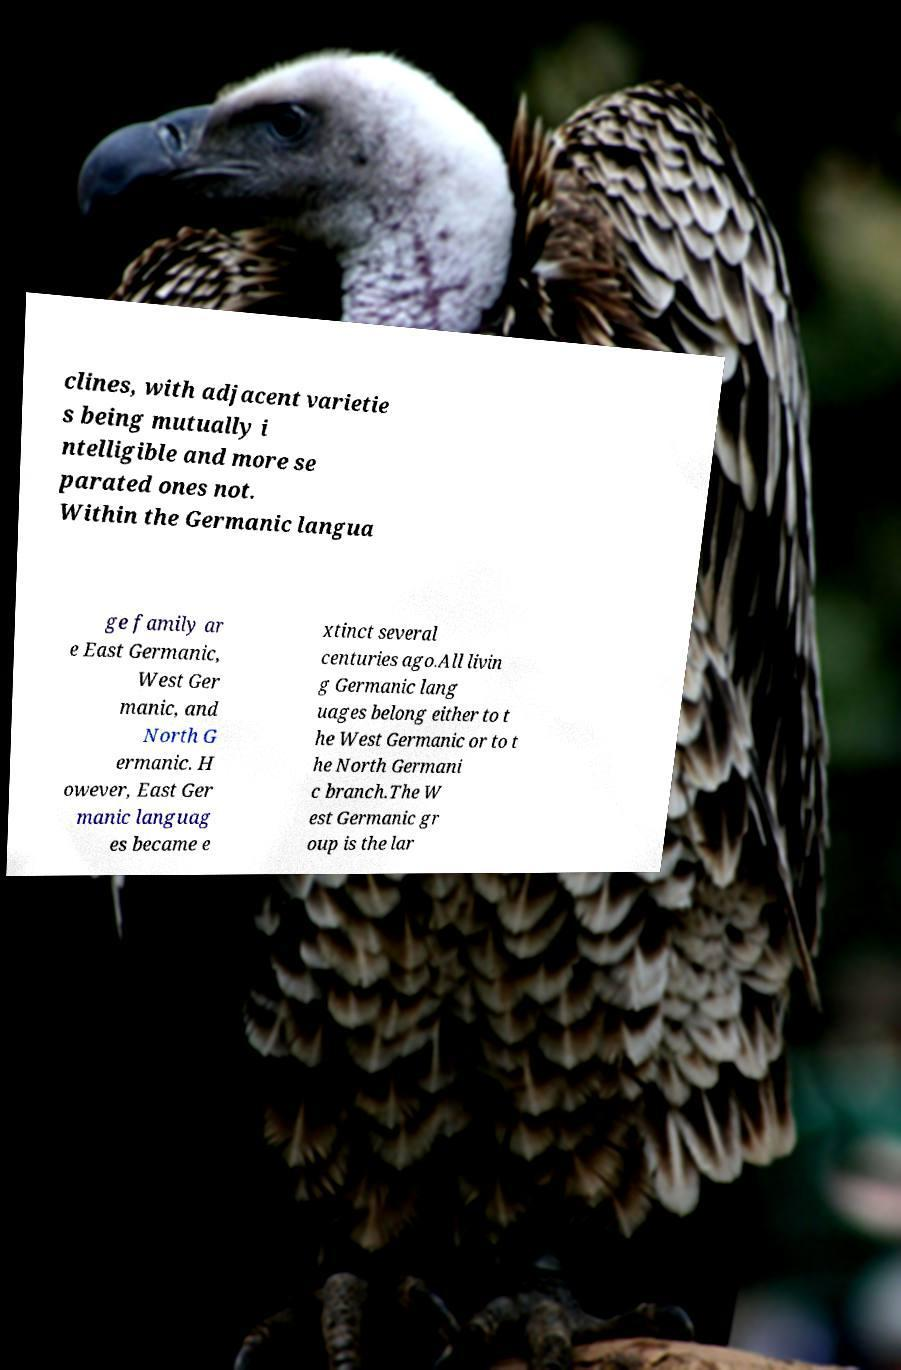Could you extract and type out the text from this image? clines, with adjacent varietie s being mutually i ntelligible and more se parated ones not. Within the Germanic langua ge family ar e East Germanic, West Ger manic, and North G ermanic. H owever, East Ger manic languag es became e xtinct several centuries ago.All livin g Germanic lang uages belong either to t he West Germanic or to t he North Germani c branch.The W est Germanic gr oup is the lar 